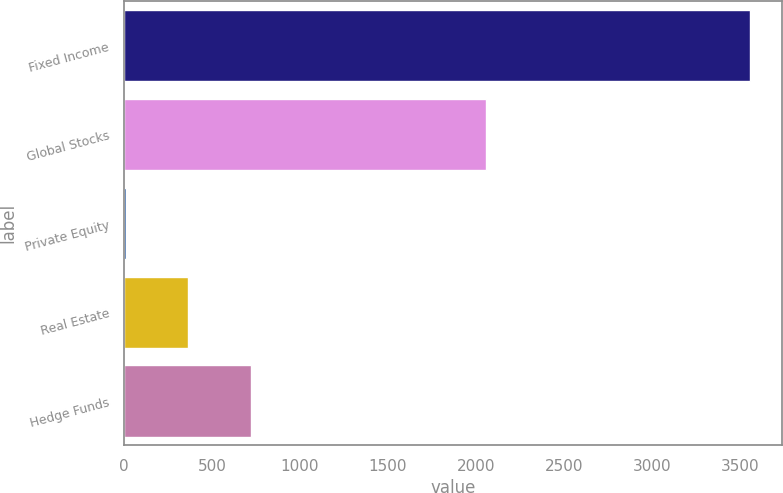Convert chart to OTSL. <chart><loc_0><loc_0><loc_500><loc_500><bar_chart><fcel>Fixed Income<fcel>Global Stocks<fcel>Private Equity<fcel>Real Estate<fcel>Hedge Funds<nl><fcel>3560<fcel>2055<fcel>10<fcel>365<fcel>720<nl></chart> 